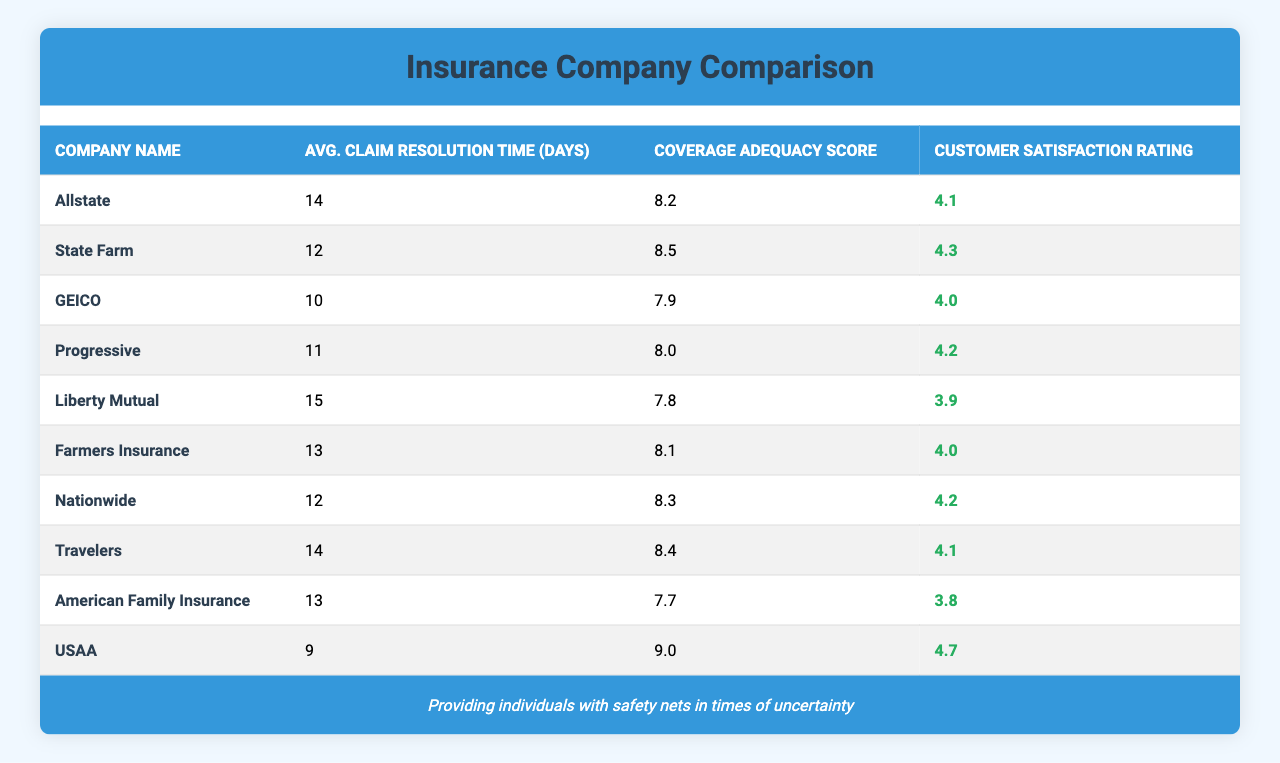What is the customer satisfaction rating for USAA? The table lists USAA's customer satisfaction rating under the respective column, which shows a value of 4.7.
Answer: 4.7 Which company has the highest coverage adequacy score? By comparing the coverage adequacy scores of all companies in the table, USAA has the highest score of 9.0.
Answer: USAA What is the average claim resolution time for Progressive and GEICO combined? The average claim resolution time for Progressive is 11 days and for GEICO is 10 days. Adding these gives 21 days, and dividing by 2 gives an average of 10.5 days.
Answer: 10.5 days Is there a company with a customer satisfaction rating of 3.8? Yes, the table indicates that American Family Insurance has a customer satisfaction rating of 3.8.
Answer: Yes Which company has the lowest customer satisfaction rating? Comparing all the customer satisfaction ratings in the table, American Family Insurance has the lowest rating of 3.8.
Answer: American Family Insurance How many companies have an average claim resolution time of 12 days? Looking through the table, both State Farm and Nationwide have an average claim resolution time of 12 days. Thus, there are two companies.
Answer: 2 What is the difference in customer satisfaction ratings between State Farm and Liberty Mutual? State Farm has a customer satisfaction rating of 4.3 and Liberty Mutual has a rating of 3.9. The difference is 4.3 - 3.9 = 0.4.
Answer: 0.4 Do any of the companies have both a higher coverage adequacy score and a lower average claim resolution time than Allstate? Yes, USAA has a higher coverage adequacy score (9.0) and a lower average claim resolution time (9 days) than Allstate, which has a score of 8.2 and a resolution time of 14 days.
Answer: Yes What is the average customer satisfaction rating for companies with an average claim resolution time less than 12 days? The companies with an average claim resolution time less than 12 days are GEICO (4.0), Progressive (4.2), and USAA (4.7). Adding these ratings gives 12.9, and dividing by 3 results in an average of 4.3.
Answer: 4.3 Which insurance company has the best combination of claim resolution time and coverage adequacy score? To determine this, you can look at both metrics. USAA has the lowest claim resolution time of 9 days and the highest coverage score of 9.0, which is a strong combination.
Answer: USAA 